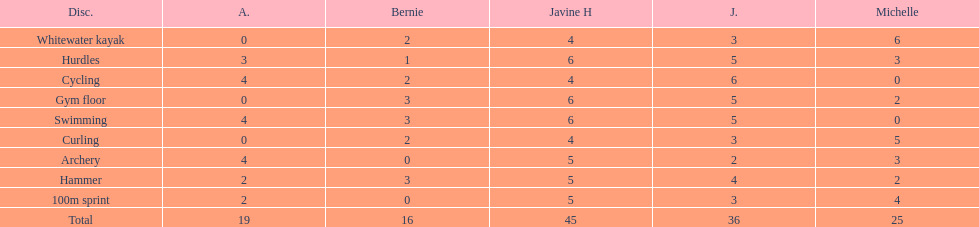In addition to amanda, who is the other girl with a 4 in cycling? Javine H. 